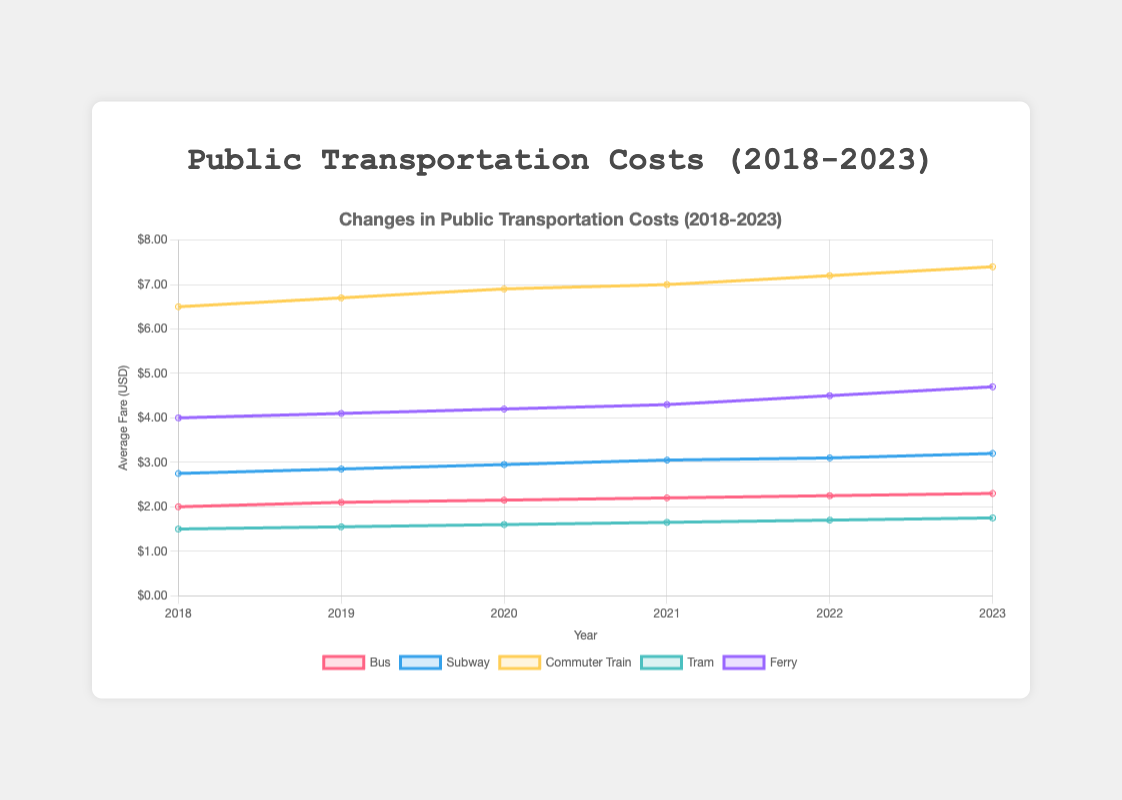What is the average increase in bus fare from 2018 to 2023? The bus fare in 2018 was $2.00, and in 2023 it was $2.30. The average increase is calculated by taking the difference (2.30 - 2.00) and then dividing by the number of years, which is 5. Thus, the average increase per year is (2.30 - 2.00) / 5.
Answer: $0.06 Which transportation type had the highest fare in 2019? By looking at the 2019 data points, the fares are: Bus: $2.10, Subway: $2.85, Commuter Train: $6.70, Tram: $1.55, Ferry: $4.10. The highest fare is for the Commuter Train at $6.70.
Answer: Commuter Train What is the total increase in tram fare from 2018 to 2023? The tram fare in 2018 was $1.50 and in 2023 it was $1.75. The total increase is calculated by subtracting the 2018 fare from the 2023 fare: 1.75 - 1.50.
Answer: $0.25 Which transportation type had the smallest percentage increase in fare from 2018 to 2023? We compute the percentage increase for each type: Bus: ((2.30 - 2.00) / 2.00) * 100 = 15%, Subway: ((3.20 - 2.75) / 2.75) * 100 = 16.36%, Commuter Train: ((7.40 - 6.50) / 6.50) * 100 ≈ 13.85%, Tram: ((1.75 - 1.50) / 1.50) * 100 ≈ 16.67%, Ferry: ((4.70 - 4.00) / 4.00) * 100 = 17.50%. The smallest percentage increase is for the Commuter Train at ≈ 13.85%.
Answer: Commuter Train In which year did the ferry fare see the highest annual increase? We calculate the annual increase by comparing consecutive years: 2018-2019: 4.10 - 4.00 = 0.10, 2019-2020: 4.20 - 4.10 = 0.10, 2020-2021: 4.30 - 4.20 = 0.10, 2021-2022: 4.50 - 4.30 = 0.20, 2022-2023: 4.70 - 4.50 = 0.20. The highest increases of $0.20 occur from 2021-2022 and 2022-2023.
Answer: 2021-2022 and 2022-2023 How much more expensive was the average subway fare compared to the average tram fare in 2020? In 2020, the average subway fare was $2.95 and the average tram fare was $1.60. The difference is calculated as 2.95 - 1.60.
Answer: $1.35 Are the costs for all types of transportation increasing every year? By examining each transportation type, we see that each year the fares increase for all types: Bus, Subway, Commuter Train, Tram, and Ferry all show increasing values every year from 2018 to 2023.
Answer: Yes What is the average fare for the commuter train over the years 2018 to 2023? The fares from 2018 to 2023 for the commuter train are: $6.50, $6.70, $6.90, $7.00, $7.20, $7.40. The average is calculated as (6.50 + 6.70 + 6.90 + 7.00 + 7.20 + 7.40) / 6 ≈ 6.95.
Answer: $6.95 